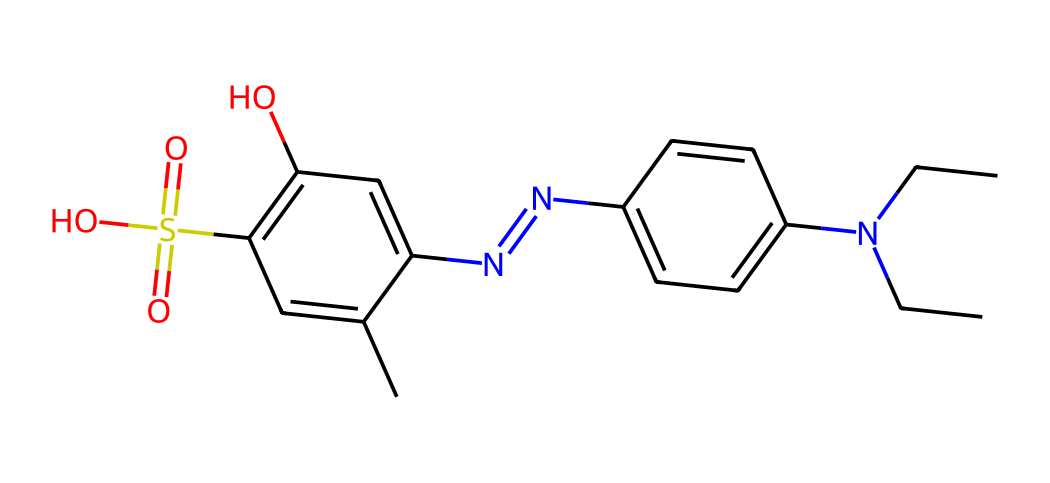What is the total number of carbon atoms in this compound? By analyzing the SMILES representation, count the 'C' atoms sequentially. Each uppercase 'C' in the SMILES notation represents a carbon atom. In this chemical, there are 16 carbon atoms.
Answer: 16 How many nitrogen atoms are present in this structure? The number of nitrogen atoms can be determined by locating 'N' in the SMILES. In this case, there are 3 nitrogen atoms in the structure.
Answer: 3 What functional group is represented by "S(=O)(=O)" in the chemical? The notation "S(=O)(=O)" indicates the presence of a sulfonic acid group. Sulfonic acids are characterized by a sulfur atom bonded to three oxygens, two of which are double-bonded.
Answer: sulfonic acid Which element gives this dye its color? The presence of conjugated systems in the molecular structure, especially from the aromatic rings and the functional groups, suggests that it is the aromatic nature of the compound that contributes to its color. Typically, chromophores in dyes give color, here it’s the molecular structure that facilitates this.
Answer: conjugated system What is the primary feature of disperse dyes beneficial for synthetic soccer turf? Disperse dyes are designed to have low solubility in water, which makes them suitable for application in synthetic fabrics including soccer turf, where they provide coloration without bleeding.
Answer: low water solubility What does the presence of amine groups imply about the properties of this dye? The presence of amine groups (indicated by 'N' connected to carbon) points to the dye's potential solubility in organic solvents and can enhance certain properties like adhesion to synthetic materials, which is crucial for durability in sports applications.
Answer: enhanced adhesion 